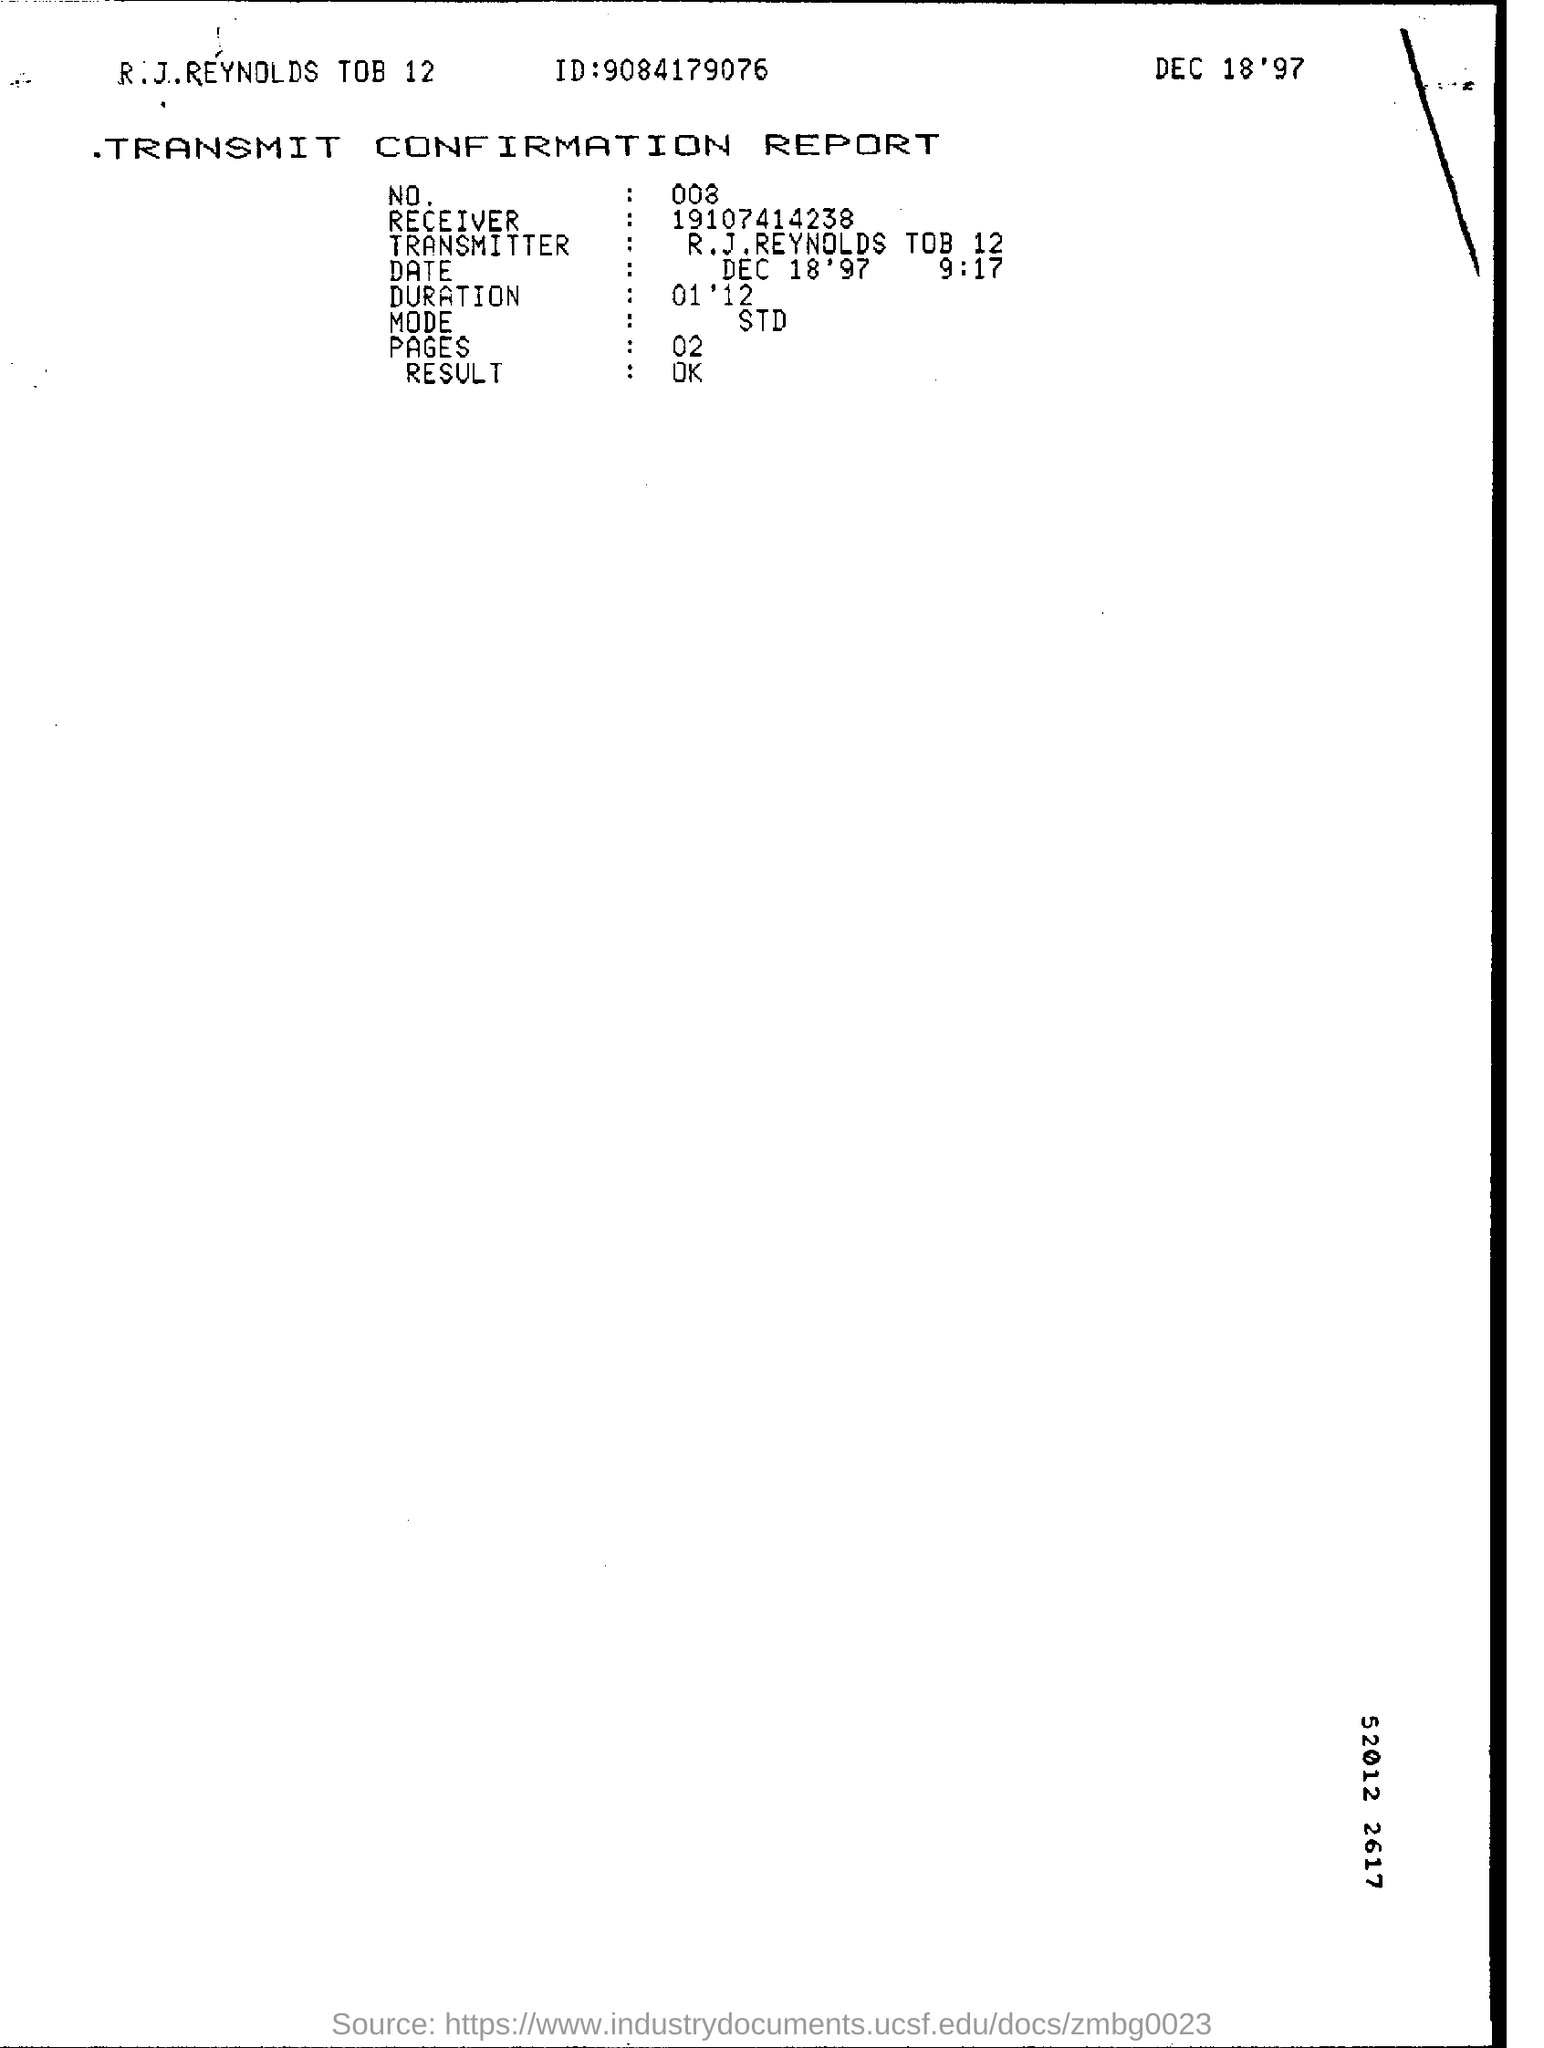Draw attention to some important aspects in this diagram. The ID is 9084179076... What is the duration? It is 01' 12 The number is 008. The transmitter is identified as R.J.REYNOLDS TOB 12. What is the number of pages? There are two pages. 